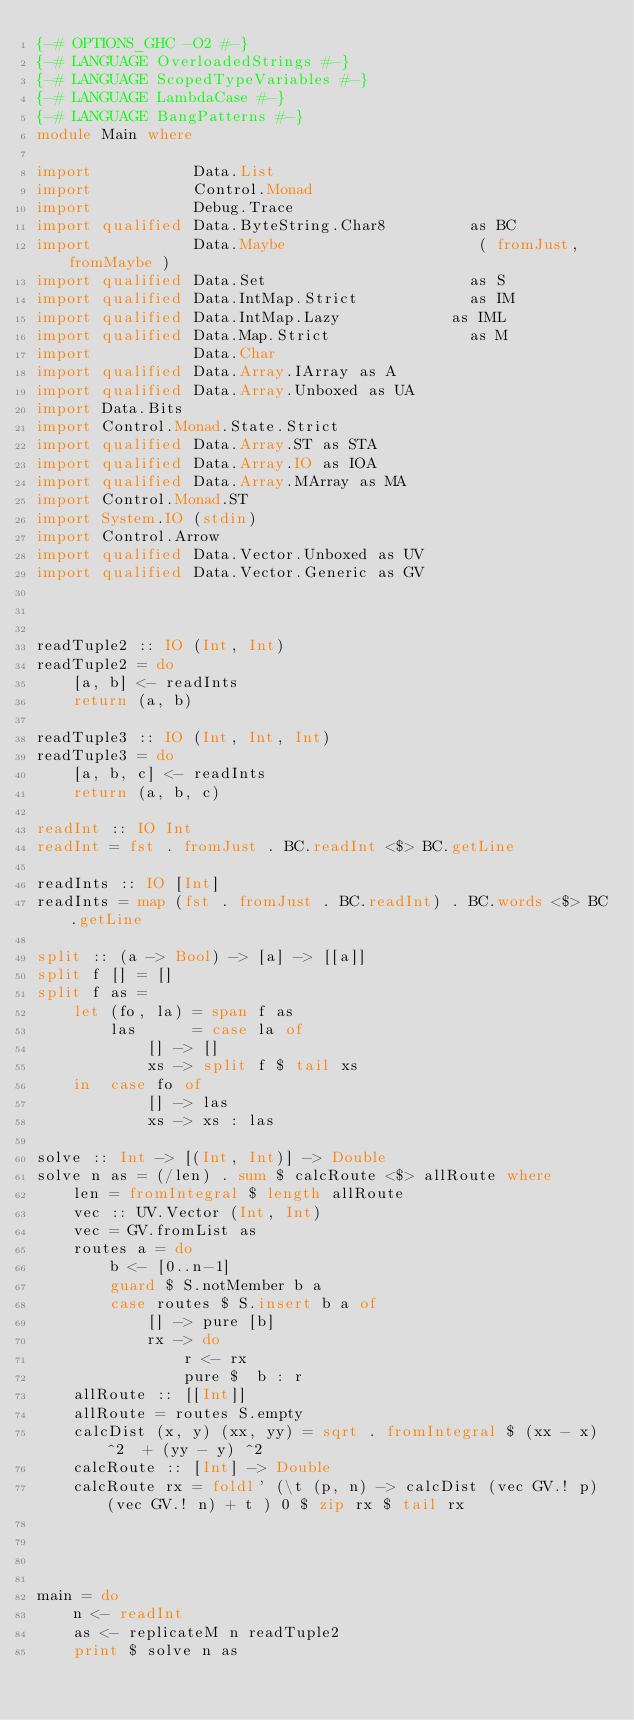<code> <loc_0><loc_0><loc_500><loc_500><_Haskell_>{-# OPTIONS_GHC -O2 #-}
{-# LANGUAGE OverloadedStrings #-}
{-# LANGUAGE ScopedTypeVariables #-}
{-# LANGUAGE LambdaCase #-}
{-# LANGUAGE BangPatterns #-}
module Main where

import           Data.List
import           Control.Monad
import           Debug.Trace
import qualified Data.ByteString.Char8         as BC
import           Data.Maybe                     ( fromJust, fromMaybe )
import qualified Data.Set                      as S
import qualified Data.IntMap.Strict            as IM
import qualified Data.IntMap.Lazy            as IML
import qualified Data.Map.Strict               as M
import           Data.Char
import qualified Data.Array.IArray as A
import qualified Data.Array.Unboxed as UA
import Data.Bits
import Control.Monad.State.Strict
import qualified Data.Array.ST as STA
import qualified Data.Array.IO as IOA
import qualified Data.Array.MArray as MA
import Control.Monad.ST
import System.IO (stdin)
import Control.Arrow
import qualified Data.Vector.Unboxed as UV
import qualified Data.Vector.Generic as GV



readTuple2 :: IO (Int, Int)
readTuple2 = do
    [a, b] <- readInts
    return (a, b)

readTuple3 :: IO (Int, Int, Int)
readTuple3 = do
    [a, b, c] <- readInts
    return (a, b, c)

readInt :: IO Int
readInt = fst . fromJust . BC.readInt <$> BC.getLine

readInts :: IO [Int]
readInts = map (fst . fromJust . BC.readInt) . BC.words <$> BC.getLine

split :: (a -> Bool) -> [a] -> [[a]]
split f [] = []
split f as =
    let (fo, la) = span f as
        las      = case la of
            [] -> []
            xs -> split f $ tail xs
    in  case fo of
            [] -> las
            xs -> xs : las

solve :: Int -> [(Int, Int)] -> Double
solve n as = (/len) . sum $ calcRoute <$> allRoute where
    len = fromIntegral $ length allRoute
    vec :: UV.Vector (Int, Int)
    vec = GV.fromList as
    routes a = do
        b <- [0..n-1]
        guard $ S.notMember b a
        case routes $ S.insert b a of
            [] -> pure [b]
            rx -> do 
                r <- rx
                pure $  b : r
    allRoute :: [[Int]]
    allRoute = routes S.empty
    calcDist (x, y) (xx, yy) = sqrt . fromIntegral $ (xx - x) ^2  + (yy - y) ^2
    calcRoute :: [Int] -> Double
    calcRoute rx = foldl' (\t (p, n) -> calcDist (vec GV.! p) (vec GV.! n) + t ) 0 $ zip rx $ tail rx




main = do
    n <- readInt
    as <- replicateM n readTuple2
    print $ solve n as
</code> 